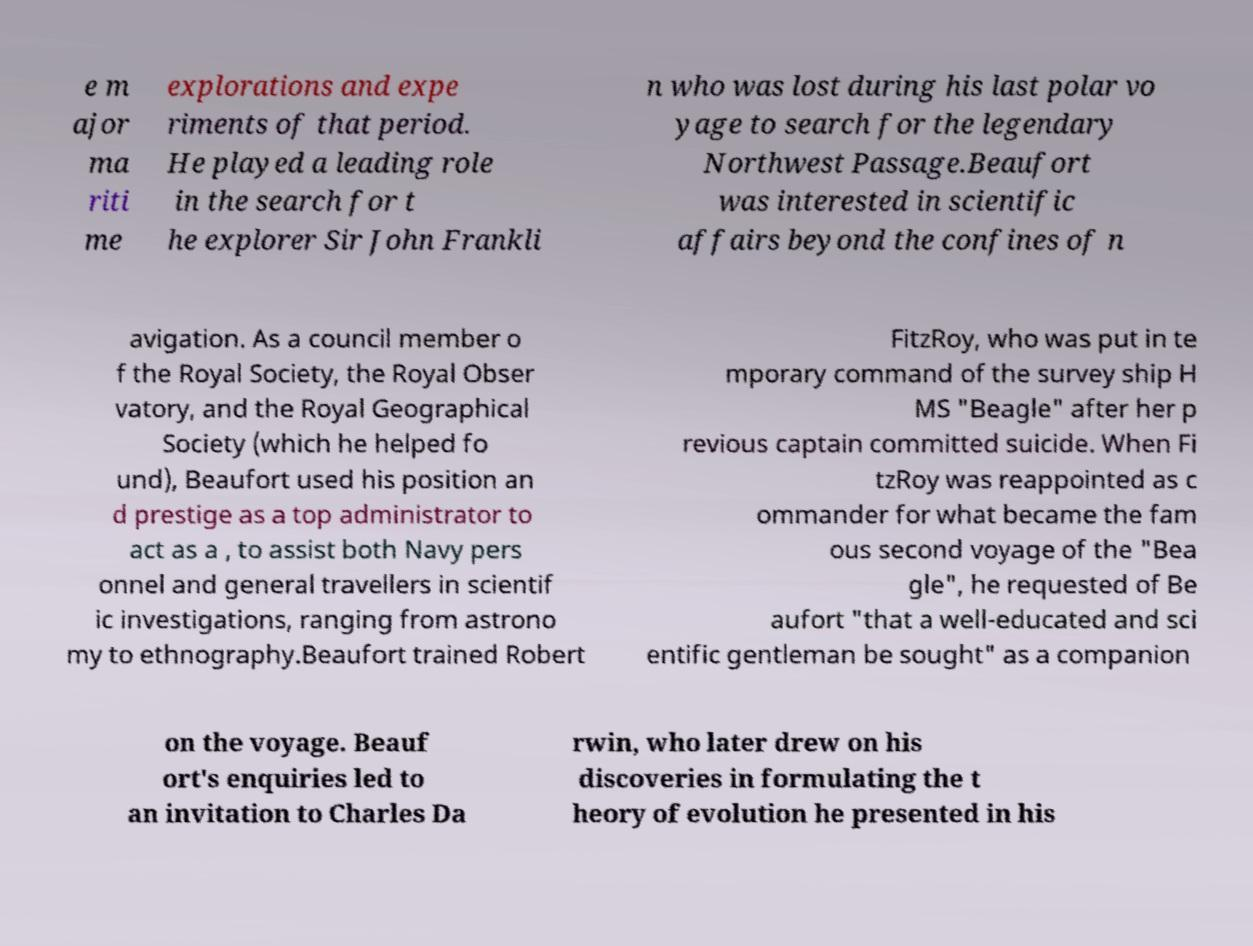Please read and relay the text visible in this image. What does it say? e m ajor ma riti me explorations and expe riments of that period. He played a leading role in the search for t he explorer Sir John Frankli n who was lost during his last polar vo yage to search for the legendary Northwest Passage.Beaufort was interested in scientific affairs beyond the confines of n avigation. As a council member o f the Royal Society, the Royal Obser vatory, and the Royal Geographical Society (which he helped fo und), Beaufort used his position an d prestige as a top administrator to act as a , to assist both Navy pers onnel and general travellers in scientif ic investigations, ranging from astrono my to ethnography.Beaufort trained Robert FitzRoy, who was put in te mporary command of the survey ship H MS "Beagle" after her p revious captain committed suicide. When Fi tzRoy was reappointed as c ommander for what became the fam ous second voyage of the "Bea gle", he requested of Be aufort "that a well-educated and sci entific gentleman be sought" as a companion on the voyage. Beauf ort's enquiries led to an invitation to Charles Da rwin, who later drew on his discoveries in formulating the t heory of evolution he presented in his 